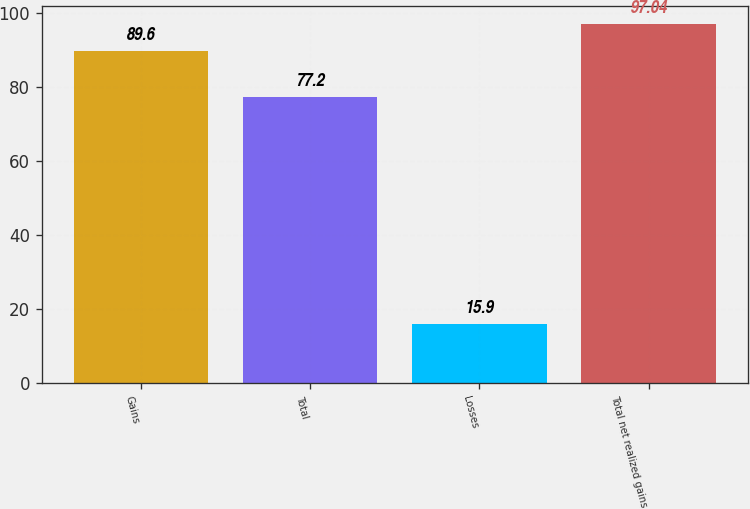Convert chart. <chart><loc_0><loc_0><loc_500><loc_500><bar_chart><fcel>Gains<fcel>Total<fcel>Losses<fcel>Total net realized gains<nl><fcel>89.6<fcel>77.2<fcel>15.9<fcel>97.04<nl></chart> 